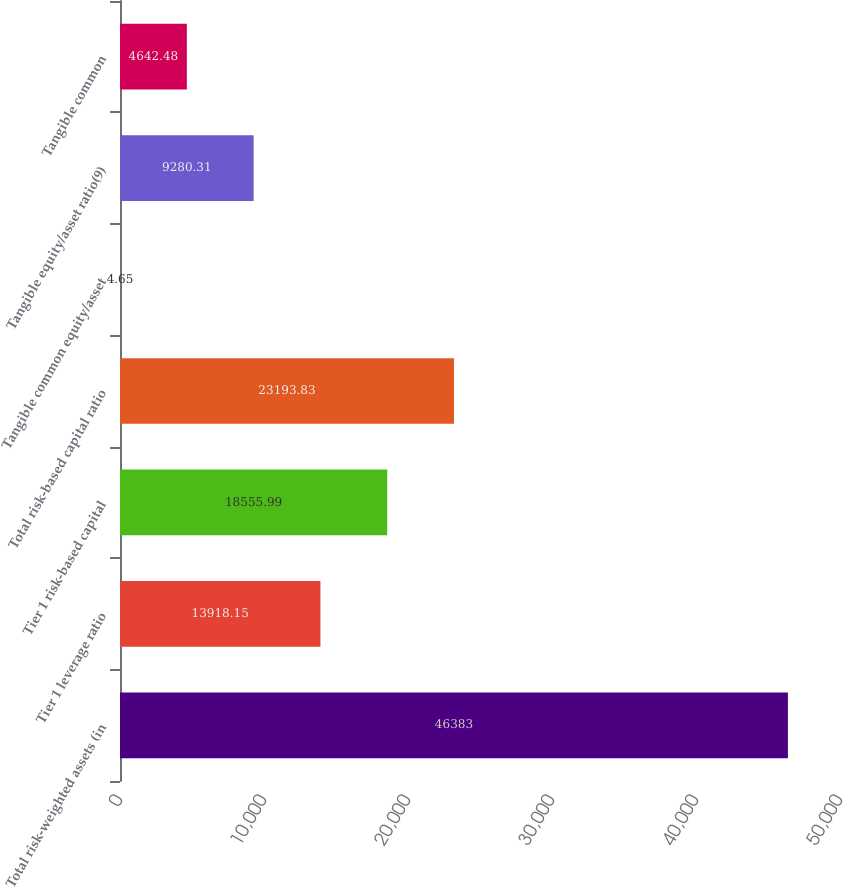Convert chart. <chart><loc_0><loc_0><loc_500><loc_500><bar_chart><fcel>Total risk-weighted assets (in<fcel>Tier 1 leverage ratio<fcel>Tier 1 risk-based capital<fcel>Total risk-based capital ratio<fcel>Tangible common equity/asset<fcel>Tangible equity/asset ratio(9)<fcel>Tangible common<nl><fcel>46383<fcel>13918.1<fcel>18556<fcel>23193.8<fcel>4.65<fcel>9280.31<fcel>4642.48<nl></chart> 